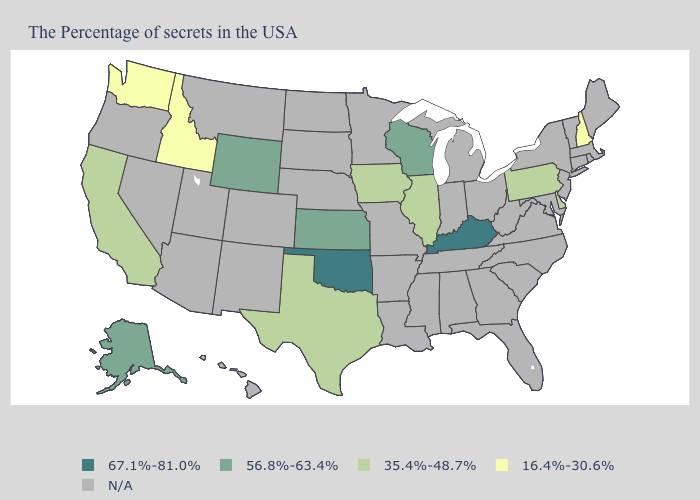What is the value of Maine?
Answer briefly. N/A. What is the highest value in the MidWest ?
Quick response, please. 56.8%-63.4%. What is the value of Michigan?
Answer briefly. N/A. Name the states that have a value in the range 67.1%-81.0%?
Quick response, please. Kentucky, Oklahoma. Is the legend a continuous bar?
Concise answer only. No. What is the value of Alabama?
Short answer required. N/A. Among the states that border Idaho , does Washington have the lowest value?
Keep it brief. Yes. Name the states that have a value in the range 67.1%-81.0%?
Be succinct. Kentucky, Oklahoma. What is the value of Utah?
Be succinct. N/A. Name the states that have a value in the range 67.1%-81.0%?
Concise answer only. Kentucky, Oklahoma. Name the states that have a value in the range 56.8%-63.4%?
Answer briefly. Wisconsin, Kansas, Wyoming, Alaska. What is the highest value in states that border Oregon?
Quick response, please. 35.4%-48.7%. Name the states that have a value in the range N/A?
Concise answer only. Maine, Massachusetts, Rhode Island, Vermont, Connecticut, New York, New Jersey, Maryland, Virginia, North Carolina, South Carolina, West Virginia, Ohio, Florida, Georgia, Michigan, Indiana, Alabama, Tennessee, Mississippi, Louisiana, Missouri, Arkansas, Minnesota, Nebraska, South Dakota, North Dakota, Colorado, New Mexico, Utah, Montana, Arizona, Nevada, Oregon, Hawaii. 